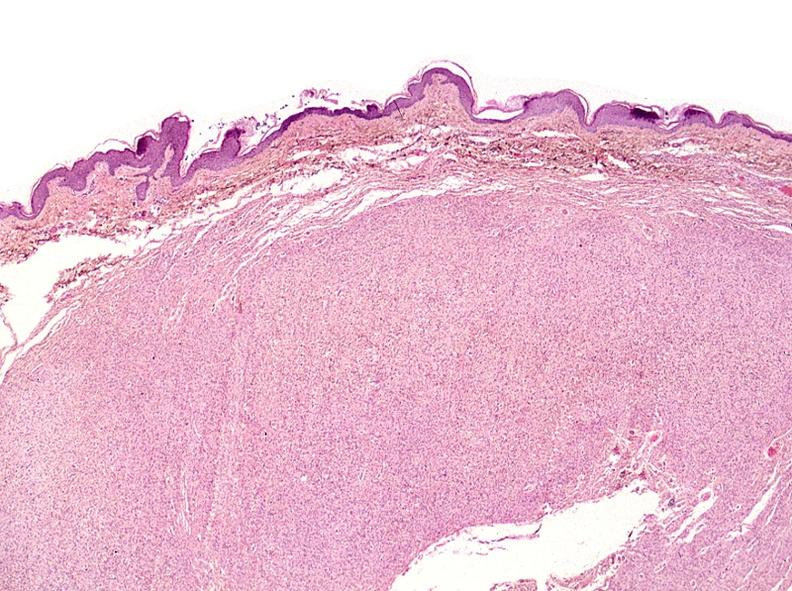does monoclonal gammopathy show skin, neurofibromatosis?
Answer the question using a single word or phrase. No 